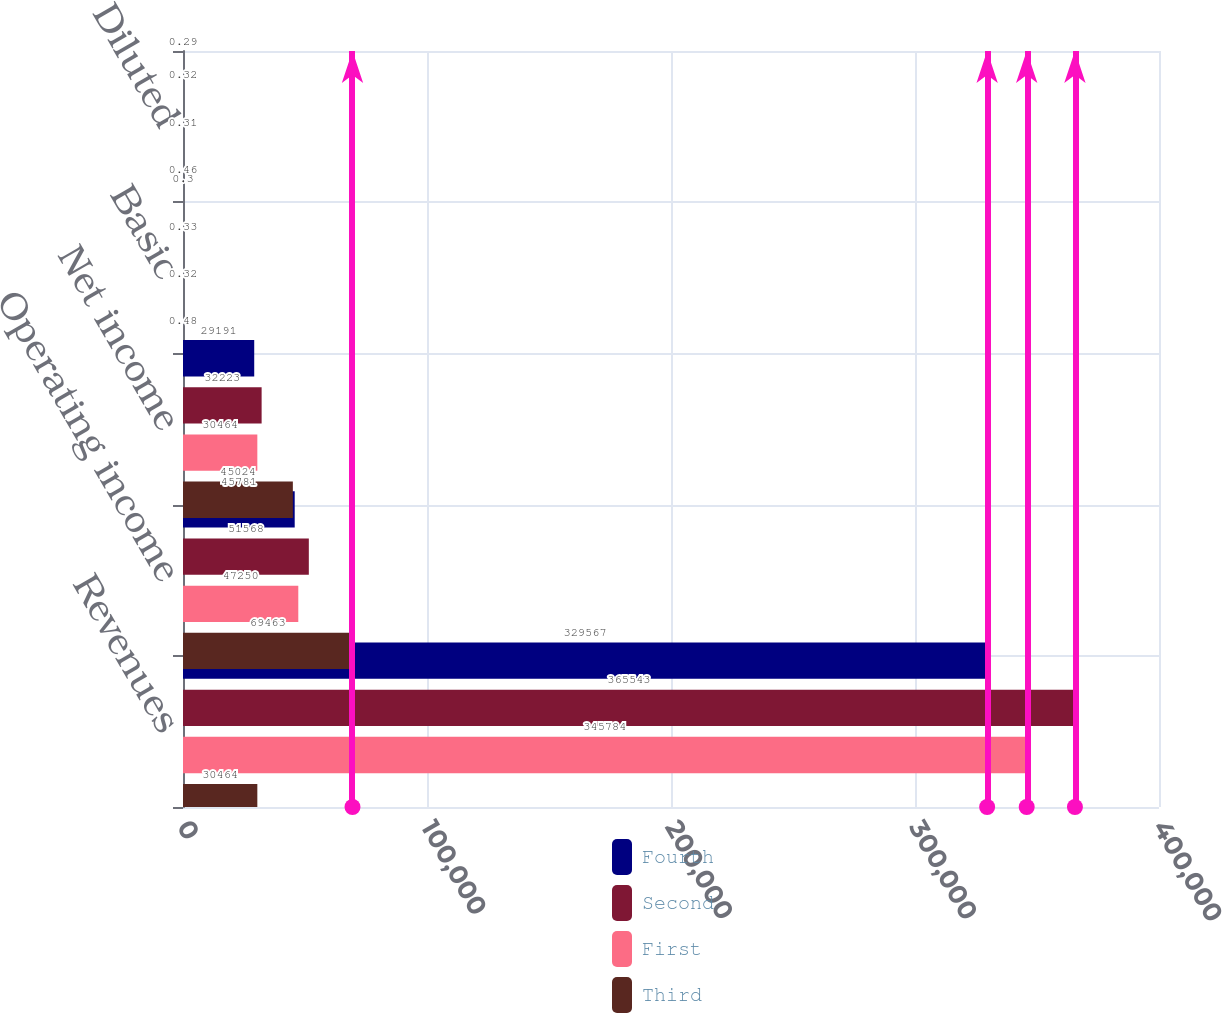Convert chart to OTSL. <chart><loc_0><loc_0><loc_500><loc_500><stacked_bar_chart><ecel><fcel>Revenues<fcel>Operating income<fcel>Net income<fcel>Basic<fcel>Diluted<nl><fcel>Fourth<fcel>329567<fcel>45781<fcel>29191<fcel>0.3<fcel>0.29<nl><fcel>Second<fcel>365543<fcel>51568<fcel>32223<fcel>0.33<fcel>0.32<nl><fcel>First<fcel>345784<fcel>47250<fcel>30464<fcel>0.32<fcel>0.31<nl><fcel>Third<fcel>30464<fcel>69463<fcel>45024<fcel>0.48<fcel>0.46<nl></chart> 